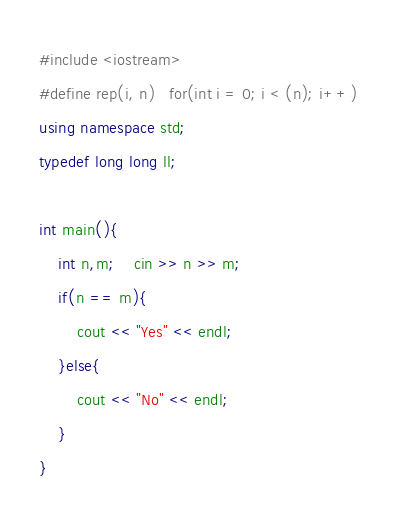Convert code to text. <code><loc_0><loc_0><loc_500><loc_500><_C++_>#include <iostream>
#define rep(i, n)   for(int i = 0; i < (n); i++)
using namespace std;
typedef long long ll;

int main(){
    int n,m;    cin >> n >> m;
    if(n == m){
        cout << "Yes" << endl;
    }else{
        cout << "No" << endl;
    }
}
</code> 